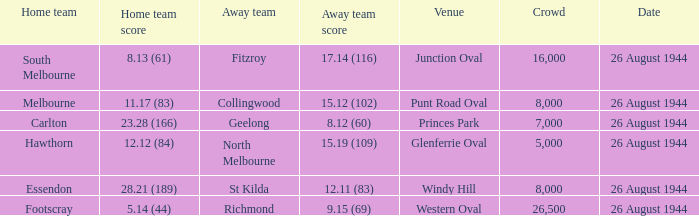What's the average crowd size when the Home team is melbourne? 8000.0. 